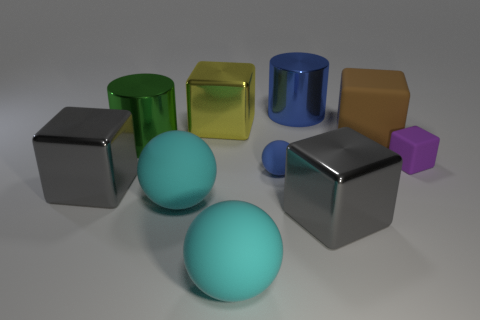Does the blue object that is behind the tiny purple matte block have the same shape as the green metallic object?
Ensure brevity in your answer.  Yes. What material is the large thing that is the same color as the tiny ball?
Your response must be concise. Metal. What number of large cylinders are the same color as the small matte sphere?
Provide a succinct answer. 1. There is a matte object that is to the right of the matte object behind the small purple matte cube; what is its shape?
Make the answer very short. Cube. Is there another blue matte thing of the same shape as the large blue thing?
Your answer should be compact. No. There is a small cube; is its color the same as the cylinder in front of the large brown matte object?
Offer a very short reply. No. What is the size of the metallic thing that is the same color as the small ball?
Ensure brevity in your answer.  Large. Is there a purple thing that has the same size as the brown rubber object?
Give a very brief answer. No. Is the brown thing made of the same material as the tiny block that is right of the blue rubber ball?
Keep it short and to the point. Yes. Are there more small cyan shiny cylinders than green metallic cylinders?
Offer a terse response. No. 